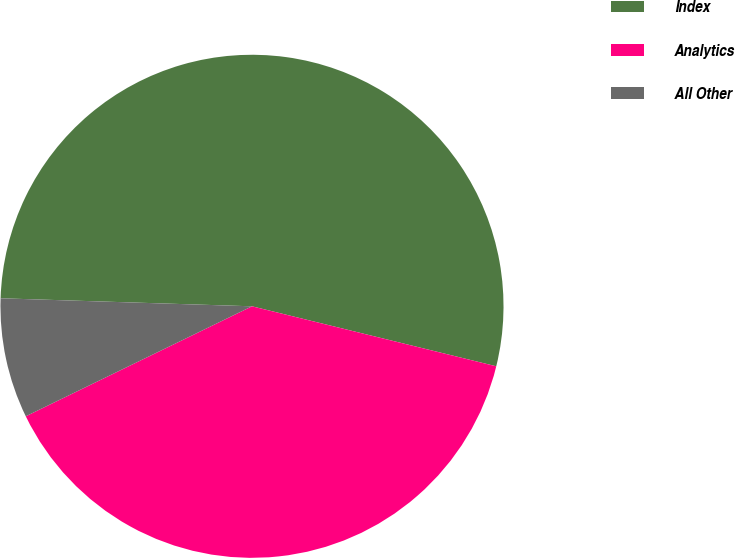<chart> <loc_0><loc_0><loc_500><loc_500><pie_chart><fcel>Index<fcel>Analytics<fcel>All Other<nl><fcel>53.32%<fcel>38.96%<fcel>7.71%<nl></chart> 